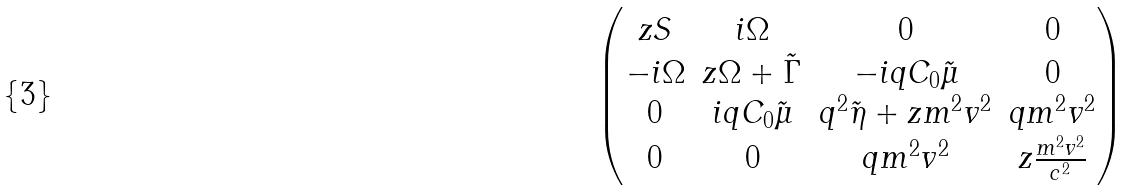Convert formula to latex. <formula><loc_0><loc_0><loc_500><loc_500>\begin{pmatrix} z S & i \Omega & 0 & 0 \\ - i \Omega & z \Omega + \tilde { \Gamma } & - i q C _ { 0 } \tilde { \mu } & 0 \\ 0 & i q C _ { 0 } \tilde { \mu } & q ^ { 2 } \tilde { \eta } + z m ^ { 2 } v ^ { 2 } & q m ^ { 2 } v ^ { 2 } \\ 0 & 0 & q m ^ { 2 } v ^ { 2 } & z \frac { m ^ { 2 } v ^ { 2 } } { c ^ { 2 } } \end{pmatrix}</formula> 